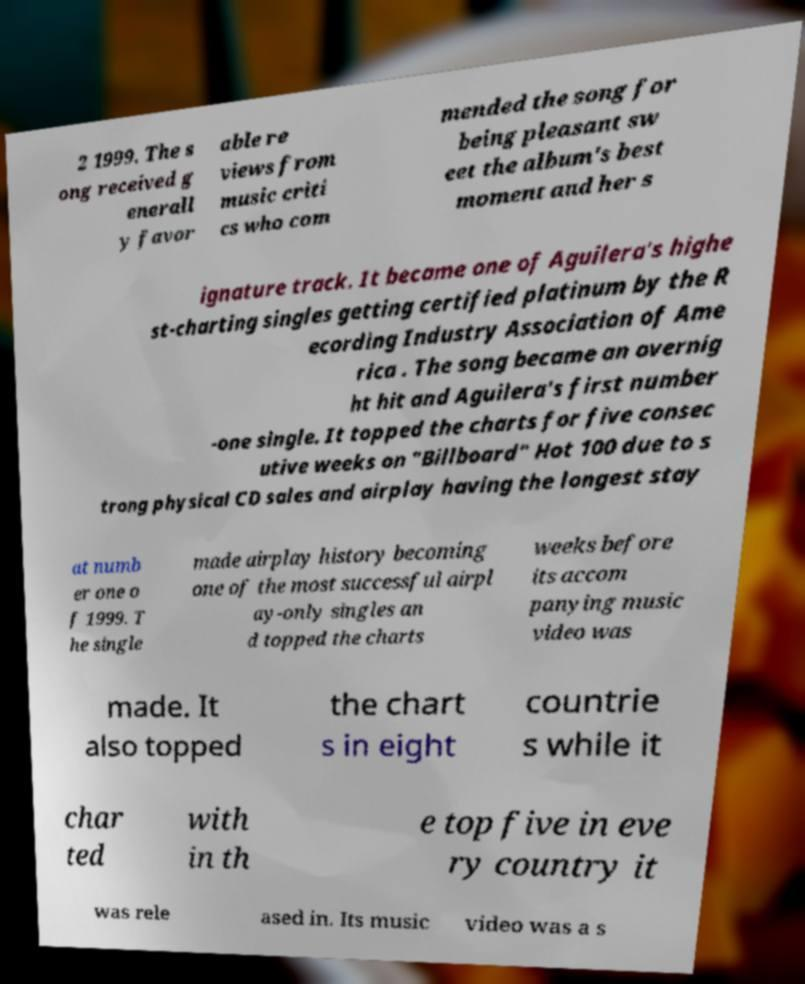There's text embedded in this image that I need extracted. Can you transcribe it verbatim? 2 1999. The s ong received g enerall y favor able re views from music criti cs who com mended the song for being pleasant sw eet the album's best moment and her s ignature track. It became one of Aguilera's highe st-charting singles getting certified platinum by the R ecording Industry Association of Ame rica . The song became an overnig ht hit and Aguilera's first number -one single. It topped the charts for five consec utive weeks on "Billboard" Hot 100 due to s trong physical CD sales and airplay having the longest stay at numb er one o f 1999. T he single made airplay history becoming one of the most successful airpl ay-only singles an d topped the charts weeks before its accom panying music video was made. It also topped the chart s in eight countrie s while it char ted with in th e top five in eve ry country it was rele ased in. Its music video was a s 